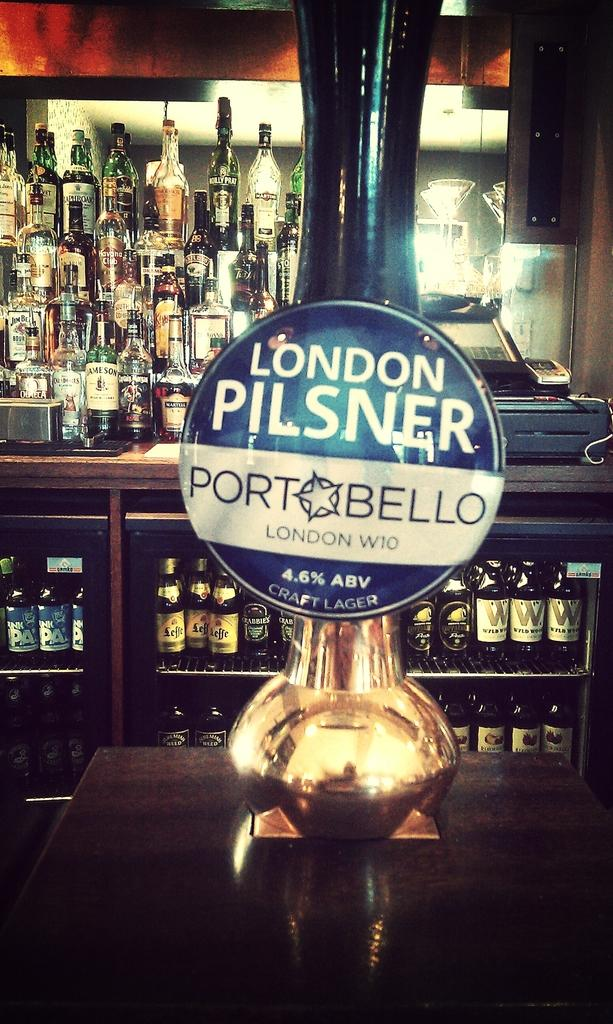<image>
Render a clear and concise summary of the photo. A beer tap  has London pilsner port bello beer. 